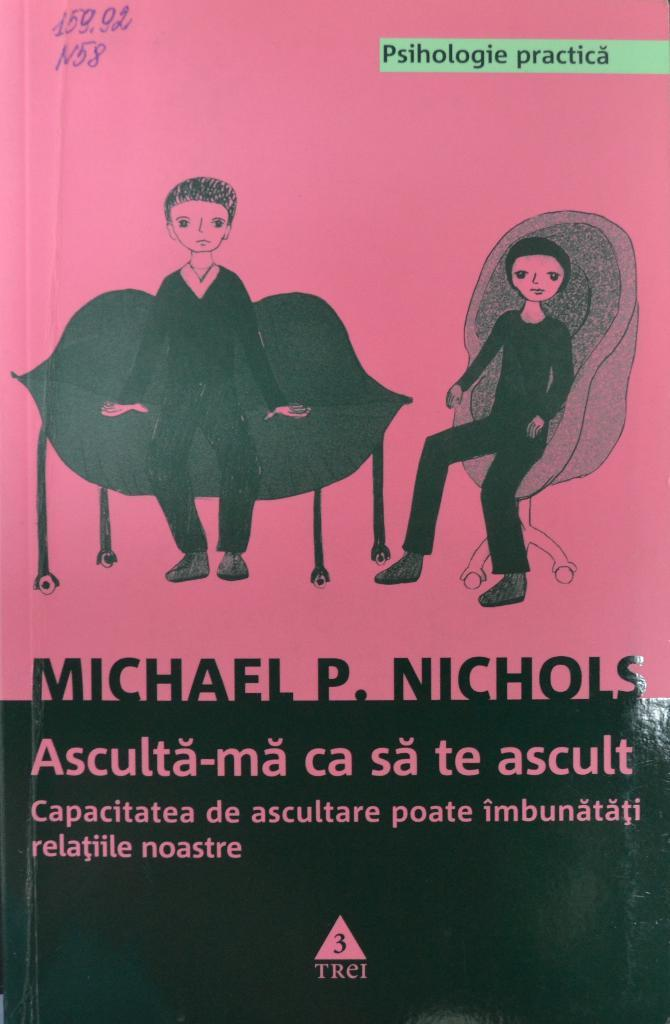What object can be seen in the image? There is a book in the image. How many cherries are on top of the book in the image? There are no cherries present in the image; it only features a book. What type of blade can be seen cutting through the pages of the book in the image? There is no blade or any indication of cutting in the image; it only shows a book. 